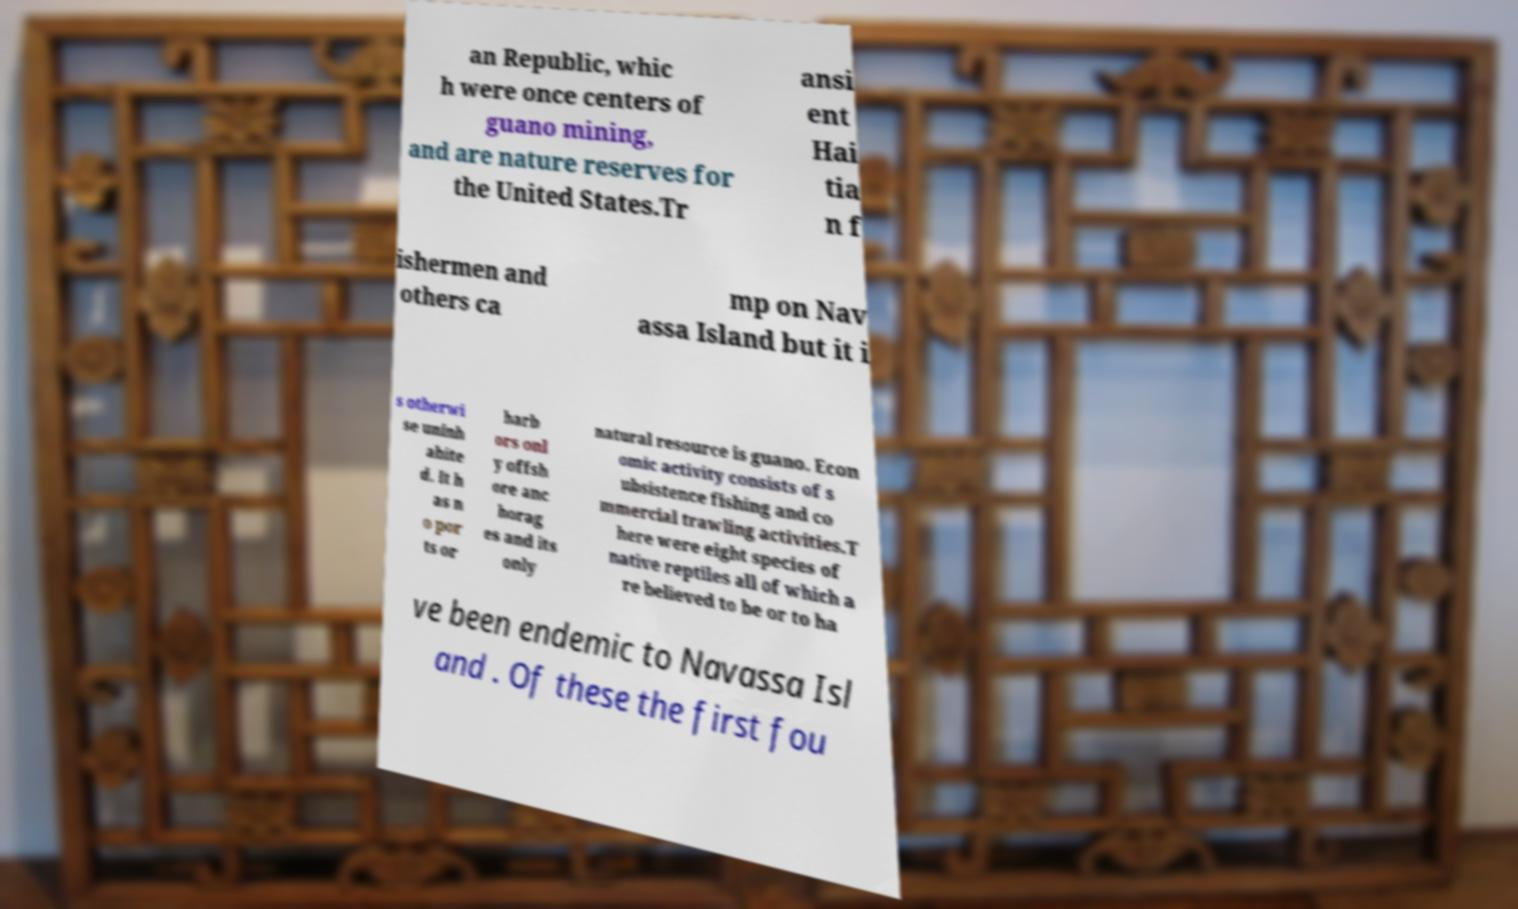Please read and relay the text visible in this image. What does it say? an Republic, whic h were once centers of guano mining, and are nature reserves for the United States.Tr ansi ent Hai tia n f ishermen and others ca mp on Nav assa Island but it i s otherwi se uninh abite d. It h as n o por ts or harb ors onl y offsh ore anc horag es and its only natural resource is guano. Econ omic activity consists of s ubsistence fishing and co mmercial trawling activities.T here were eight species of native reptiles all of which a re believed to be or to ha ve been endemic to Navassa Isl and . Of these the first fou 